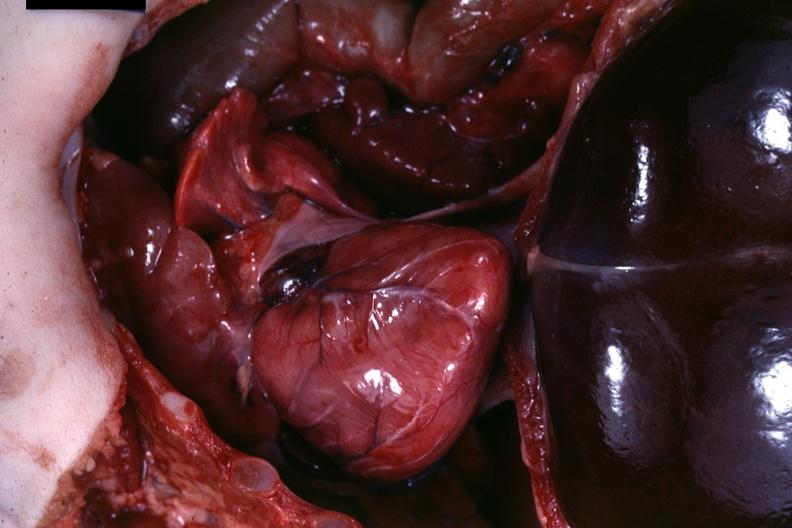does this image show opened body?
Answer the question using a single word or phrase. Yes 